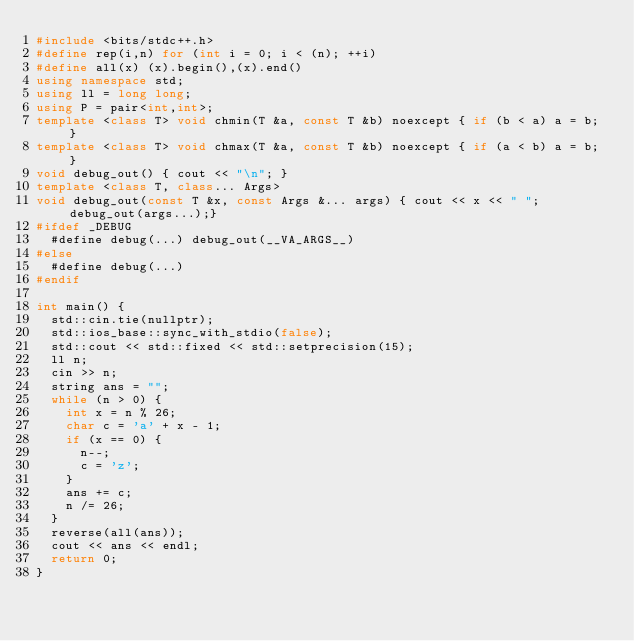<code> <loc_0><loc_0><loc_500><loc_500><_C++_>#include <bits/stdc++.h>
#define rep(i,n) for (int i = 0; i < (n); ++i)
#define all(x) (x).begin(),(x).end()
using namespace std;
using ll = long long;
using P = pair<int,int>;
template <class T> void chmin(T &a, const T &b) noexcept { if (b < a) a = b; }
template <class T> void chmax(T &a, const T &b) noexcept { if (a < b) a = b; }
void debug_out() { cout << "\n"; }
template <class T, class... Args>
void debug_out(const T &x, const Args &... args) { cout << x << " "; debug_out(args...);}
#ifdef _DEBUG
  #define debug(...) debug_out(__VA_ARGS__)
#else
  #define debug(...) 
#endif

int main() {
  std::cin.tie(nullptr);
  std::ios_base::sync_with_stdio(false);
  std::cout << std::fixed << std::setprecision(15);
  ll n;
  cin >> n;
  string ans = "";
  while (n > 0) {
    int x = n % 26;
    char c = 'a' + x - 1;
    if (x == 0) {
      n--;
      c = 'z';
    }
    ans += c;
    n /= 26;
  }
  reverse(all(ans));
  cout << ans << endl;
  return 0;
}</code> 